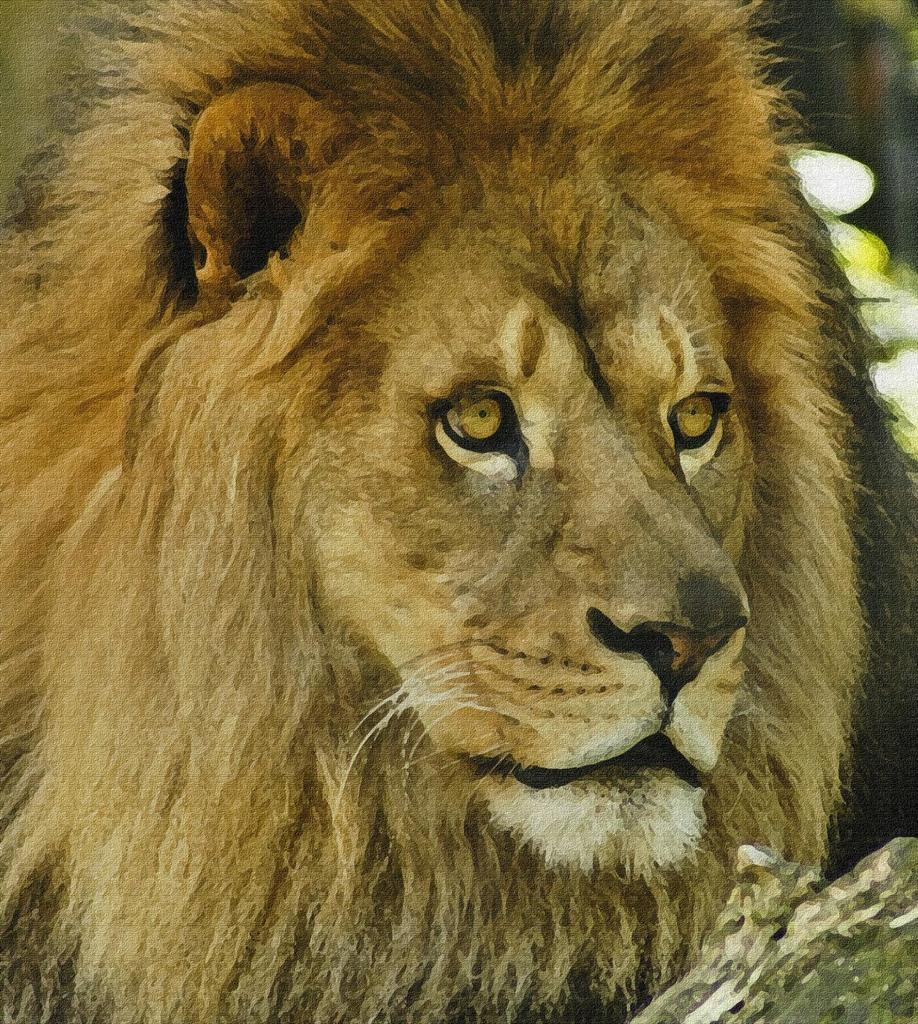What type of artwork is depicted in the image? The image appears to be a painting. What animal is featured in the painting? There is a lion in the image. What is the color of the lion in the painting? The lion is brown in color. What can be seen on the right side of the painting? There is tree bark on the right side of the image. How many friends does the lion have in the painting? The painting does not depict the lion's friends, so it is not possible to determine the number of friends the lion has. 